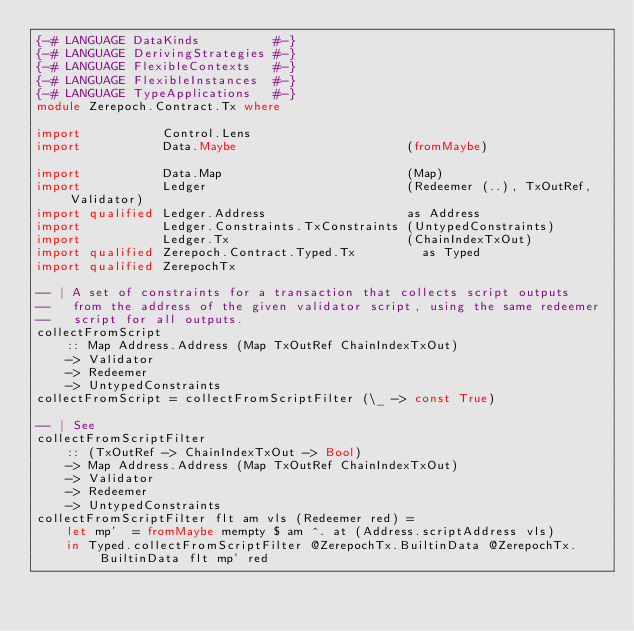<code> <loc_0><loc_0><loc_500><loc_500><_Haskell_>{-# LANGUAGE DataKinds          #-}
{-# LANGUAGE DerivingStrategies #-}
{-# LANGUAGE FlexibleContexts   #-}
{-# LANGUAGE FlexibleInstances  #-}
{-# LANGUAGE TypeApplications   #-}
module Zerepoch.Contract.Tx where

import           Control.Lens
import           Data.Maybe                       (fromMaybe)

import           Data.Map                         (Map)
import           Ledger                           (Redeemer (..), TxOutRef, Validator)
import qualified Ledger.Address                   as Address
import           Ledger.Constraints.TxConstraints (UntypedConstraints)
import           Ledger.Tx                        (ChainIndexTxOut)
import qualified Zerepoch.Contract.Typed.Tx         as Typed
import qualified ZerepochTx

-- | A set of constraints for a transaction that collects script outputs
--   from the address of the given validator script, using the same redeemer
--   script for all outputs.
collectFromScript
    :: Map Address.Address (Map TxOutRef ChainIndexTxOut)
    -> Validator
    -> Redeemer
    -> UntypedConstraints
collectFromScript = collectFromScriptFilter (\_ -> const True)

-- | See
collectFromScriptFilter
    :: (TxOutRef -> ChainIndexTxOut -> Bool)
    -> Map Address.Address (Map TxOutRef ChainIndexTxOut)
    -> Validator
    -> Redeemer
    -> UntypedConstraints
collectFromScriptFilter flt am vls (Redeemer red) =
    let mp'  = fromMaybe mempty $ am ^. at (Address.scriptAddress vls)
    in Typed.collectFromScriptFilter @ZerepochTx.BuiltinData @ZerepochTx.BuiltinData flt mp' red
</code> 